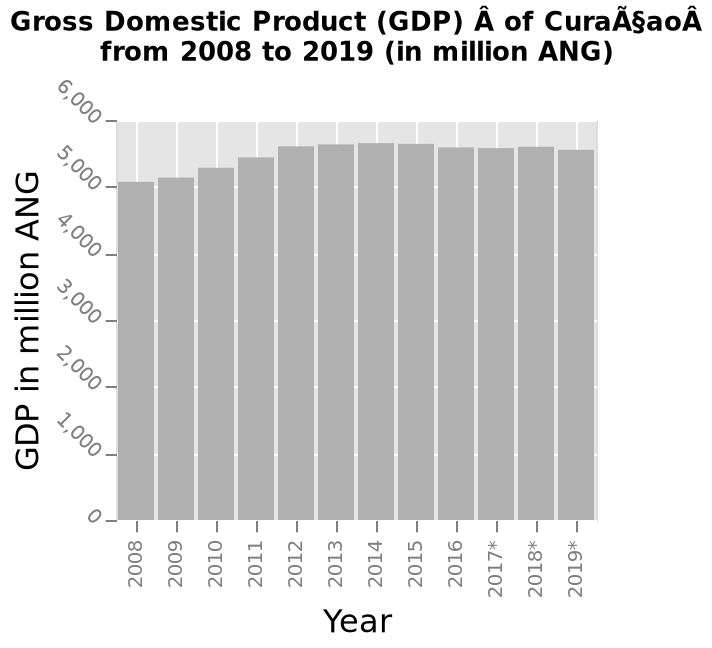<image>
 What is the highest GDP value shown on the bar chart?  The highest GDP value shown on the bar chart is 6,000 million ANG. What is the stability level of CuraASSaoA's GDP between 2008 and 2019? The stability level of CuraASSaoA's GDP between 2008 and 2019 is fairly high as it remained unchanged. 